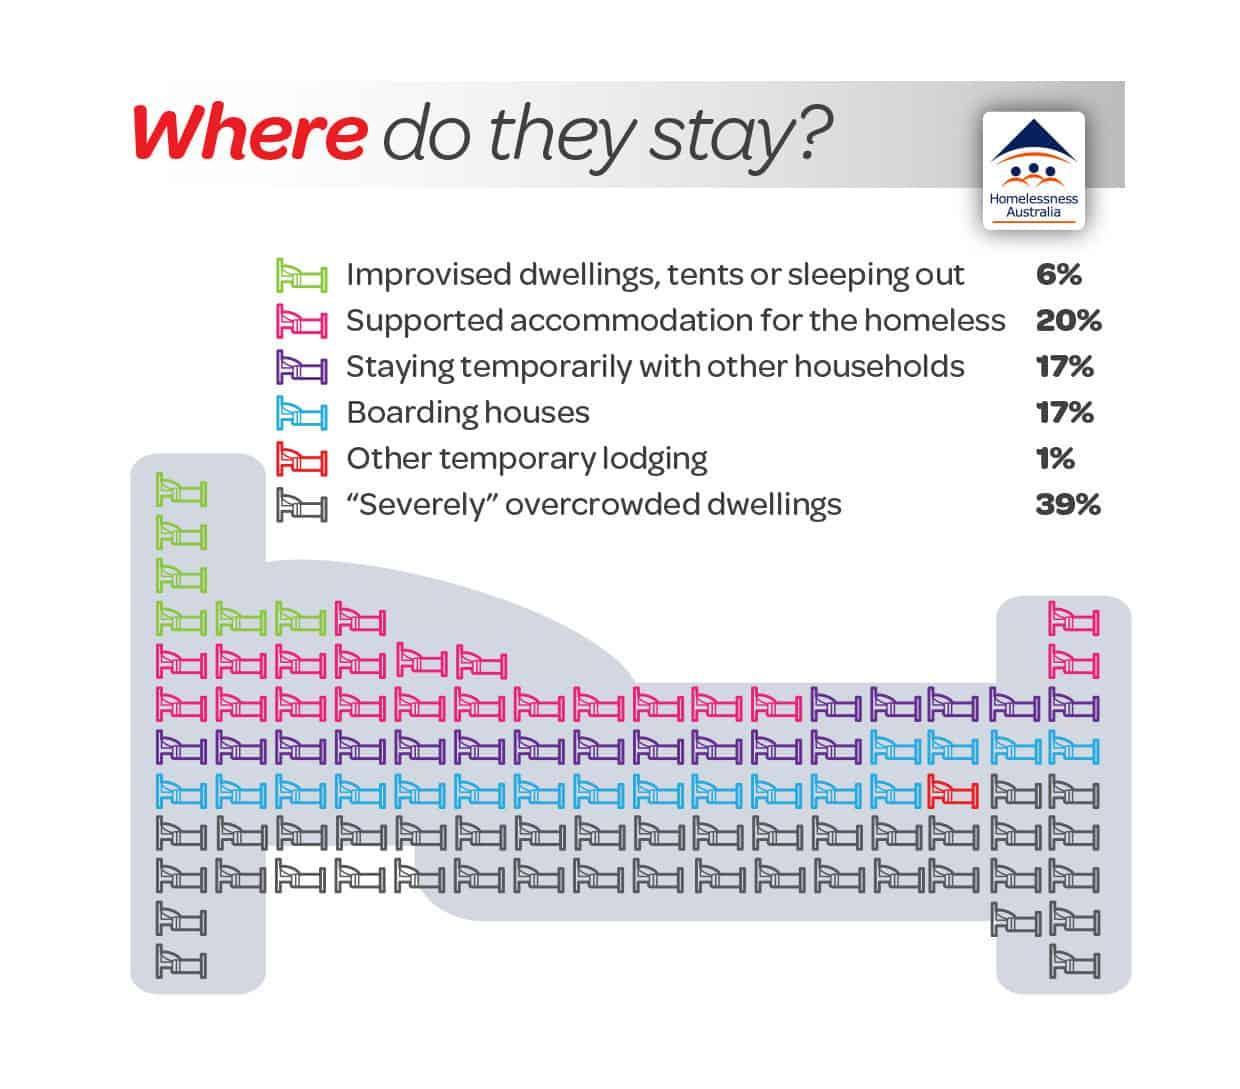Where does the second highest percentage of population stay?
Answer the question with a short phrase. Supported accommodation for the homeless Which type of accommodation is represented in the image with a blue bed? Boarding houses Which color is used to represent Other temporary lodging - pink, green or red? red What percentage of population stay in the type of accommodation denoted by a green bed? 6 